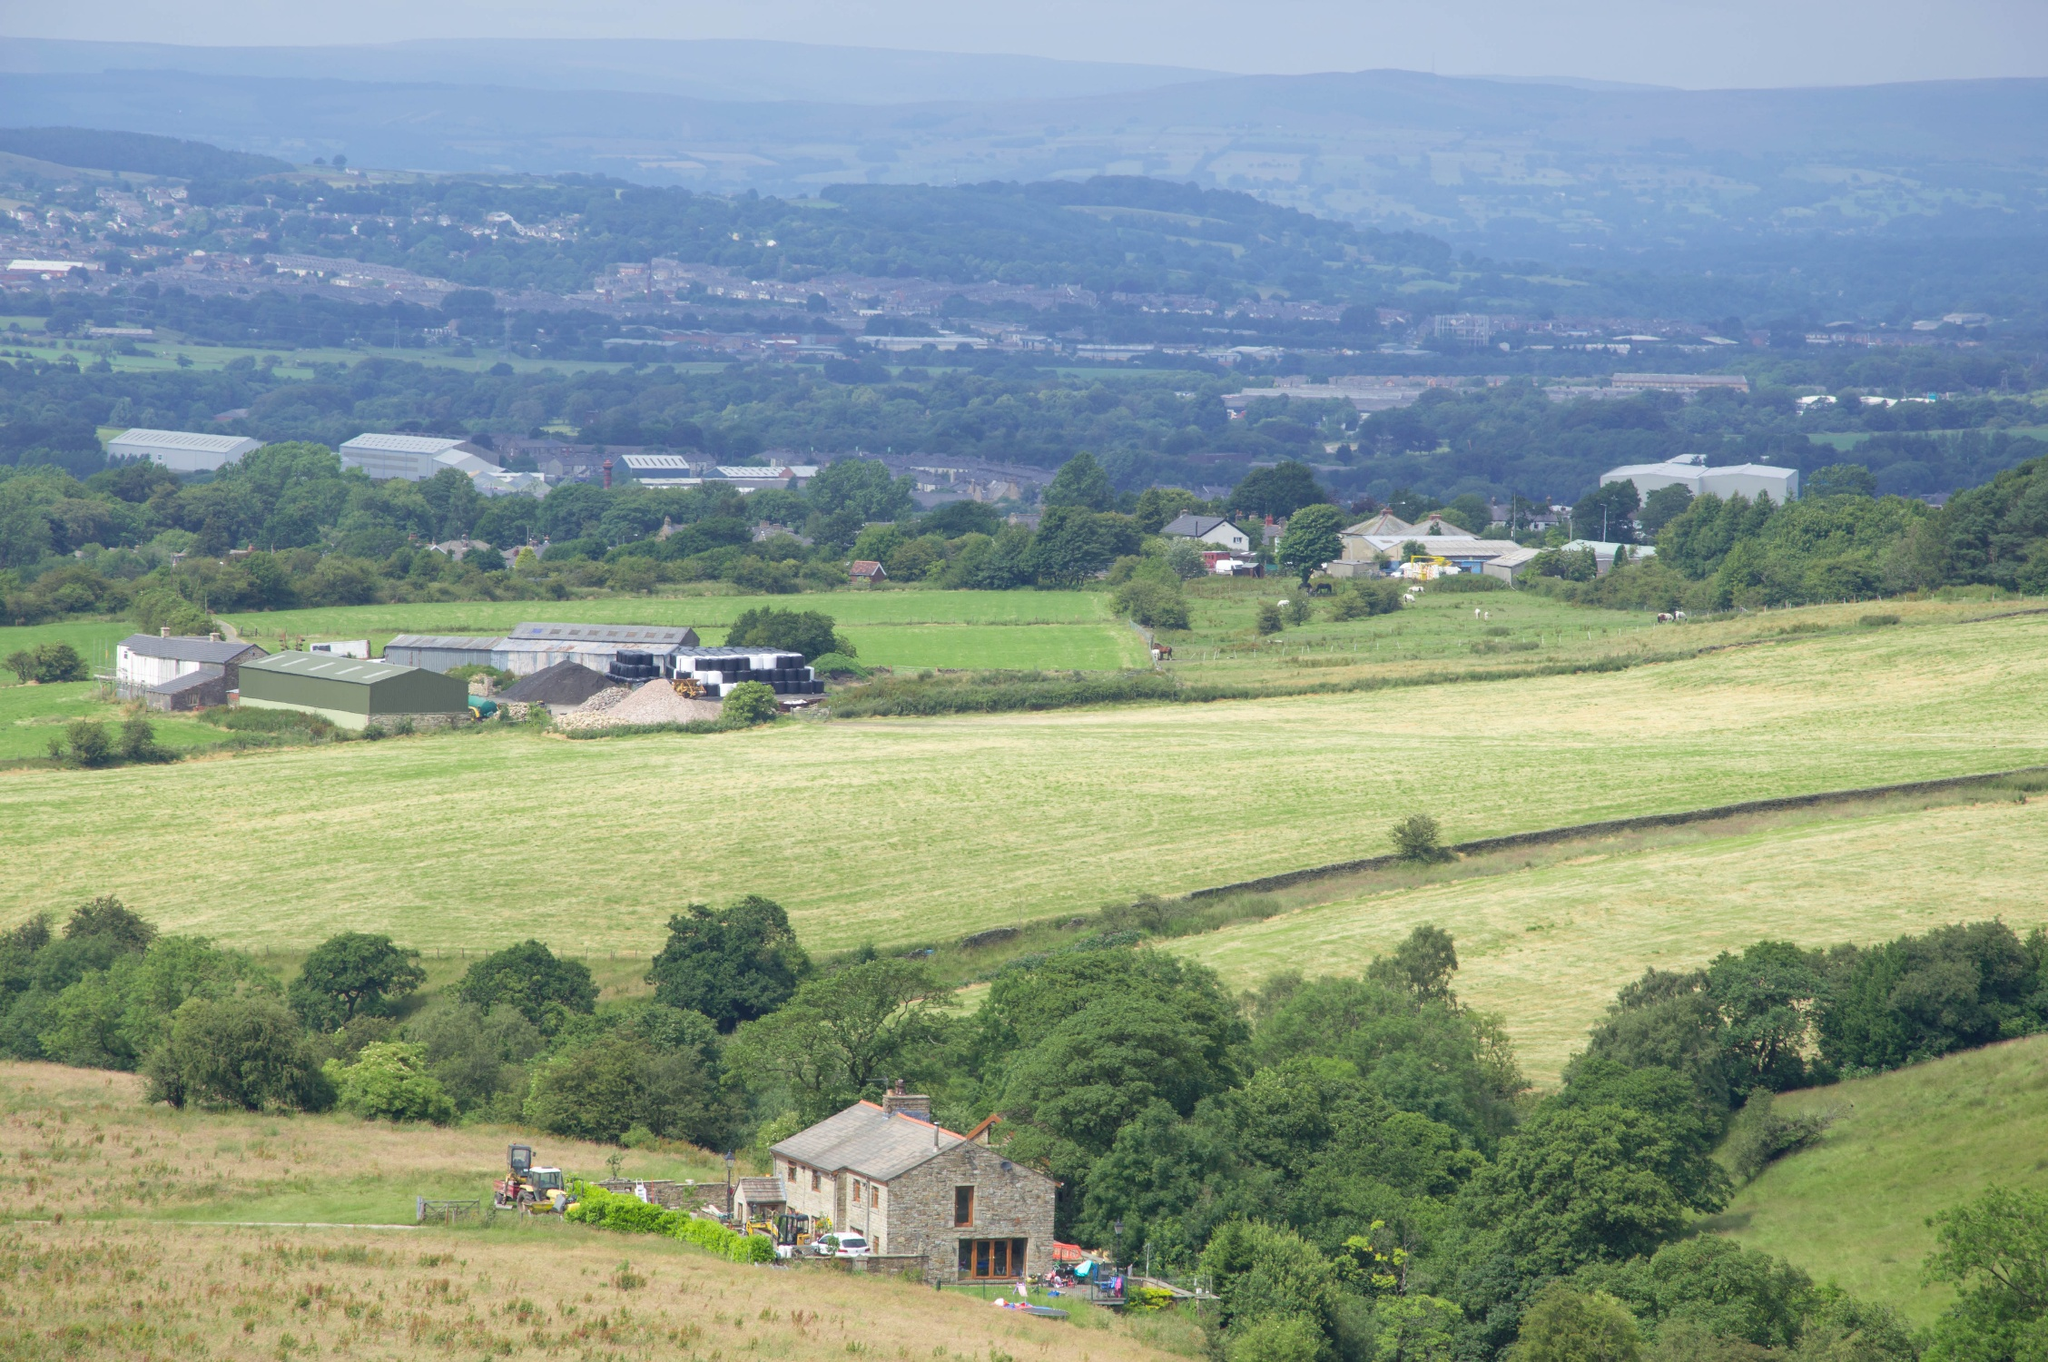Describe the following image. The image provides a panoramic view of a picturesque countryside setting prominently featuring a quaint village. The village, comprising several scattered buildings, sits elegantly amidst expansive fields that show a mix of agricultural activity. Shades of green in varying intensities cover most of the terrain, indicating lush, well-cared-for crops, alongside patches of yellow that suggest either mature crops or freshly tilled soil. The sporadically placed trees add a touch of ruggedness to the otherwise manicured landscape. On the horizon, rolling hills frame the view, which is completed by a clear sky with minimal cloud cover, suggesting a calm, pleasant weather. This specific landscape is typical of rural areas where farming is predominant, and it evokes a sense of peace and simplicity. 